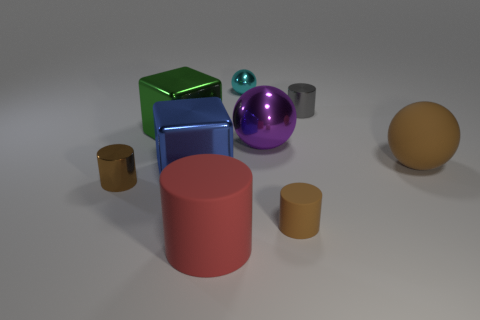How many matte things have the same color as the rubber sphere?
Your response must be concise. 1. Is the size of the green object the same as the brown matte cylinder?
Your response must be concise. No. How big is the rubber cylinder that is to the left of the brown cylinder to the right of the large cylinder?
Give a very brief answer. Large. Do the large shiny ball and the metallic cylinder to the right of the small brown shiny cylinder have the same color?
Offer a terse response. No. Is there a gray object of the same size as the red matte cylinder?
Your response must be concise. No. There is a matte cylinder that is on the right side of the big red object; what is its size?
Offer a terse response. Small. Are there any big balls that are in front of the matte cylinder that is right of the big red thing?
Your response must be concise. No. What number of other things are there of the same shape as the big blue thing?
Provide a succinct answer. 1. Do the tiny brown metallic thing and the tiny cyan metallic object have the same shape?
Your response must be concise. No. What is the color of the sphere that is both in front of the tiny cyan shiny object and on the left side of the tiny rubber thing?
Provide a succinct answer. Purple. 